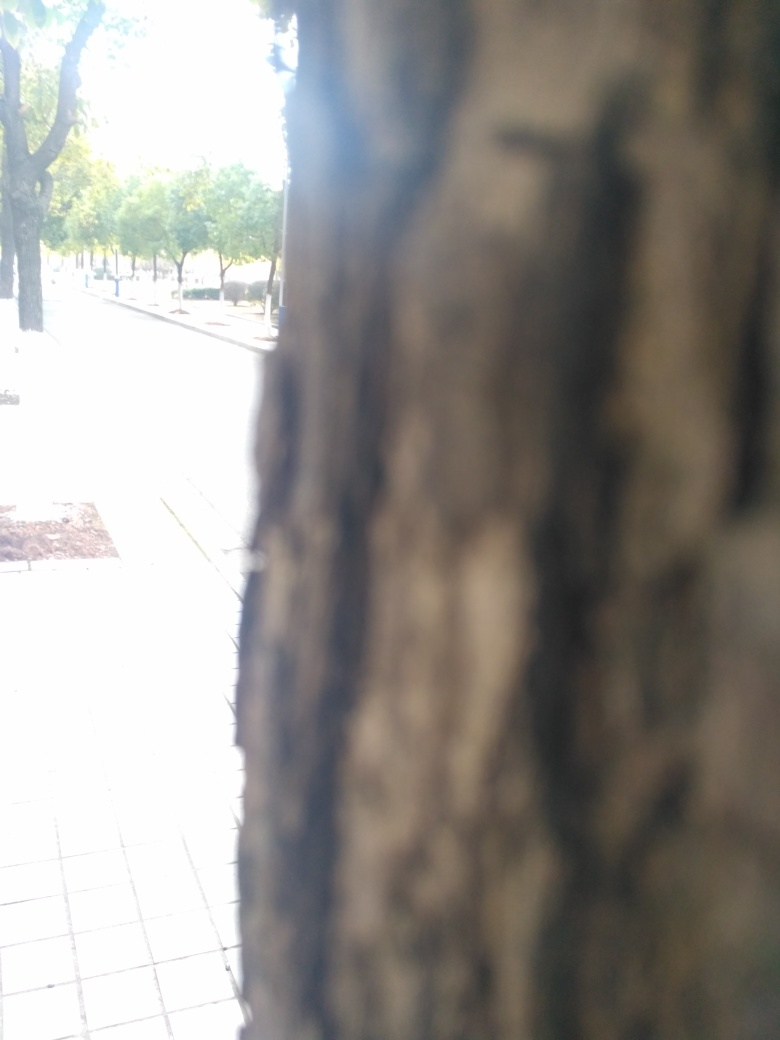What can be seen on both sides of the road?
A. cars
B. buildings
C. trees
Answer with the option's letter from the given choices directly.
 C. 